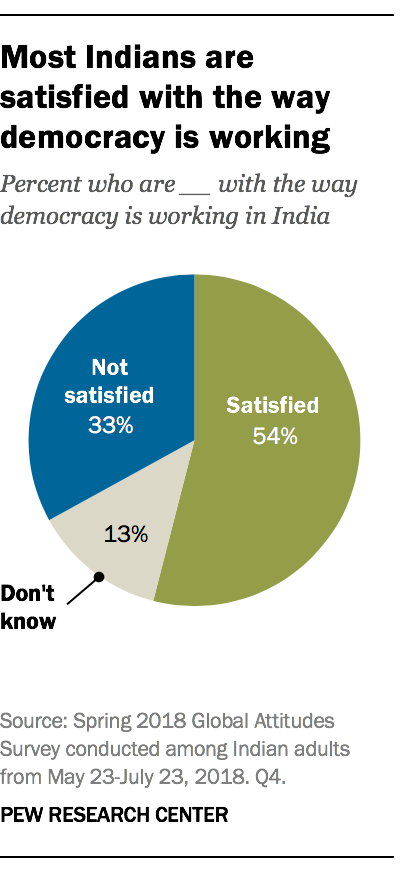Specify some key components in this picture. The pie graph displays three colors: blue, grey, and green. The difference in value between 'Not satisfied' and 'Don't know' is 20.. 